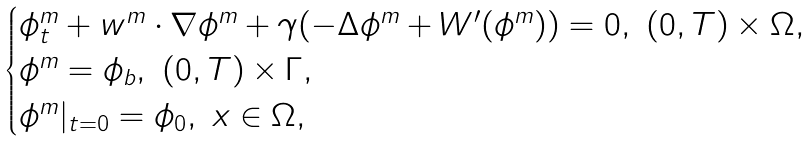<formula> <loc_0><loc_0><loc_500><loc_500>\begin{cases} \phi ^ { m } _ { t } + w ^ { m } \cdot \nabla \phi ^ { m } + \gamma ( - \Delta \phi ^ { m } + W ^ { \prime } ( \phi ^ { m } ) ) = 0 , \ ( 0 , T ) \times \Omega , \\ \phi ^ { m } = \phi _ { b } , \ ( 0 , T ) \times \Gamma , \\ \phi ^ { m } | _ { t = 0 } = \phi _ { 0 } , \ x \in \Omega , \end{cases}</formula> 